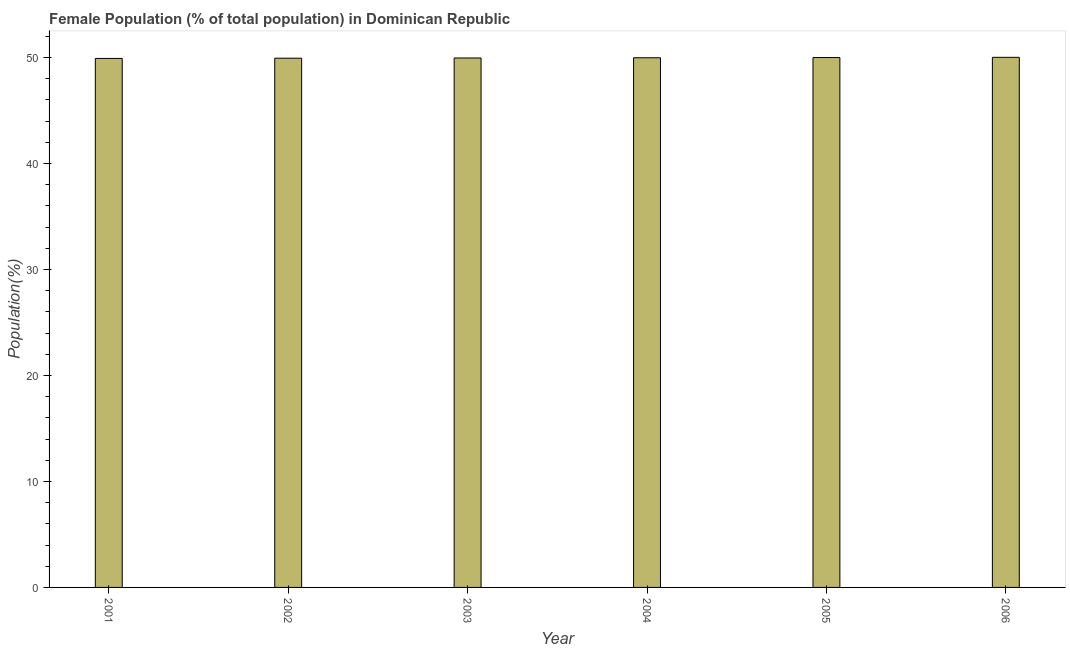Does the graph contain grids?
Your response must be concise. No. What is the title of the graph?
Your response must be concise. Female Population (% of total population) in Dominican Republic. What is the label or title of the X-axis?
Keep it short and to the point. Year. What is the label or title of the Y-axis?
Provide a short and direct response. Population(%). What is the female population in 2004?
Keep it short and to the point. 49.97. Across all years, what is the maximum female population?
Provide a succinct answer. 50.01. Across all years, what is the minimum female population?
Offer a terse response. 49.91. In which year was the female population minimum?
Make the answer very short. 2001. What is the sum of the female population?
Provide a succinct answer. 299.74. What is the difference between the female population in 2002 and 2004?
Your answer should be compact. -0.04. What is the average female population per year?
Keep it short and to the point. 49.96. What is the median female population?
Provide a short and direct response. 49.96. Is the sum of the female population in 2002 and 2003 greater than the maximum female population across all years?
Your answer should be compact. Yes. In how many years, is the female population greater than the average female population taken over all years?
Keep it short and to the point. 3. Are all the bars in the graph horizontal?
Make the answer very short. No. How many years are there in the graph?
Your answer should be compact. 6. What is the Population(%) in 2001?
Your answer should be compact. 49.91. What is the Population(%) in 2002?
Provide a succinct answer. 49.93. What is the Population(%) in 2003?
Your answer should be very brief. 49.95. What is the Population(%) of 2004?
Give a very brief answer. 49.97. What is the Population(%) in 2005?
Keep it short and to the point. 49.99. What is the Population(%) in 2006?
Make the answer very short. 50.01. What is the difference between the Population(%) in 2001 and 2002?
Your answer should be compact. -0.02. What is the difference between the Population(%) in 2001 and 2003?
Your response must be concise. -0.04. What is the difference between the Population(%) in 2001 and 2004?
Keep it short and to the point. -0.06. What is the difference between the Population(%) in 2001 and 2005?
Your response must be concise. -0.08. What is the difference between the Population(%) in 2001 and 2006?
Provide a succinct answer. -0.1. What is the difference between the Population(%) in 2002 and 2003?
Make the answer very short. -0.02. What is the difference between the Population(%) in 2002 and 2004?
Your answer should be compact. -0.04. What is the difference between the Population(%) in 2002 and 2005?
Offer a terse response. -0.06. What is the difference between the Population(%) in 2002 and 2006?
Keep it short and to the point. -0.08. What is the difference between the Population(%) in 2003 and 2004?
Make the answer very short. -0.02. What is the difference between the Population(%) in 2003 and 2005?
Offer a very short reply. -0.04. What is the difference between the Population(%) in 2003 and 2006?
Your answer should be compact. -0.06. What is the difference between the Population(%) in 2004 and 2005?
Give a very brief answer. -0.02. What is the difference between the Population(%) in 2004 and 2006?
Make the answer very short. -0.04. What is the difference between the Population(%) in 2005 and 2006?
Your response must be concise. -0.02. What is the ratio of the Population(%) in 2001 to that in 2002?
Offer a very short reply. 1. What is the ratio of the Population(%) in 2002 to that in 2003?
Your answer should be compact. 1. What is the ratio of the Population(%) in 2002 to that in 2006?
Give a very brief answer. 1. What is the ratio of the Population(%) in 2004 to that in 2005?
Provide a succinct answer. 1. 